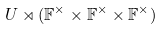Convert formula to latex. <formula><loc_0><loc_0><loc_500><loc_500>U \rtimes ( \mathbb { F } ^ { \times } \times \mathbb { F } ^ { \times } \times \mathbb { F } ^ { \times } )</formula> 